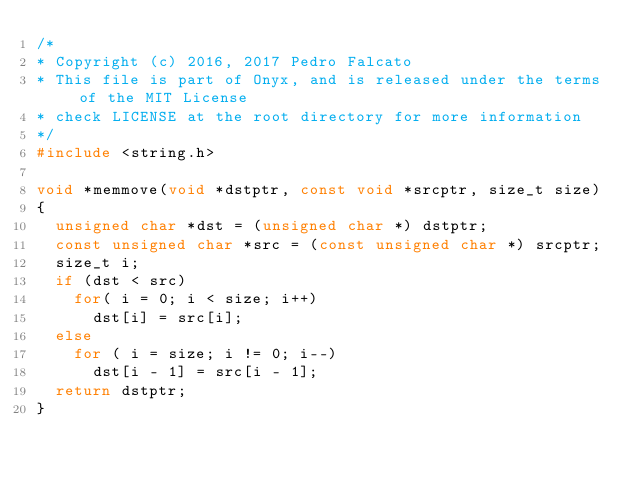<code> <loc_0><loc_0><loc_500><loc_500><_C_>/*
* Copyright (c) 2016, 2017 Pedro Falcato
* This file is part of Onyx, and is released under the terms of the MIT License
* check LICENSE at the root directory for more information
*/
#include <string.h>

void *memmove(void *dstptr, const void *srcptr, size_t size)
{
	unsigned char *dst = (unsigned char *) dstptr;
	const unsigned char *src = (const unsigned char *) srcptr;
	size_t i;
	if (dst < src)
		for( i = 0; i < size; i++)
			dst[i] = src[i];
	else
		for ( i = size; i != 0; i--)
			dst[i - 1] = src[i - 1];
	return dstptr;
}
</code> 